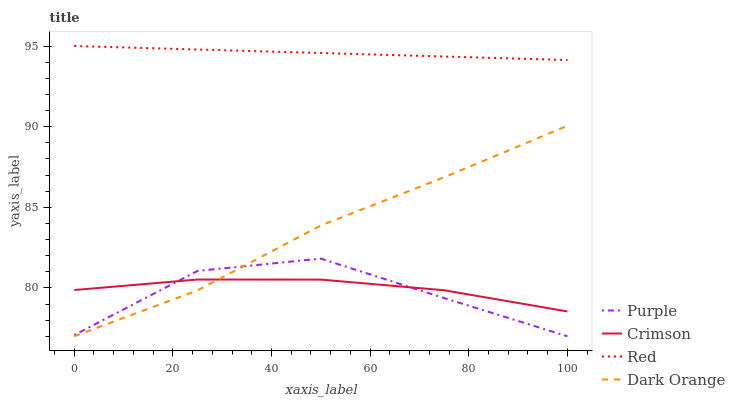Does Purple have the minimum area under the curve?
Answer yes or no. Yes. Does Red have the maximum area under the curve?
Answer yes or no. Yes. Does Crimson have the minimum area under the curve?
Answer yes or no. No. Does Crimson have the maximum area under the curve?
Answer yes or no. No. Is Red the smoothest?
Answer yes or no. Yes. Is Purple the roughest?
Answer yes or no. Yes. Is Crimson the smoothest?
Answer yes or no. No. Is Crimson the roughest?
Answer yes or no. No. Does Purple have the lowest value?
Answer yes or no. Yes. Does Crimson have the lowest value?
Answer yes or no. No. Does Red have the highest value?
Answer yes or no. Yes. Does Crimson have the highest value?
Answer yes or no. No. Is Dark Orange less than Red?
Answer yes or no. Yes. Is Red greater than Purple?
Answer yes or no. Yes. Does Purple intersect Crimson?
Answer yes or no. Yes. Is Purple less than Crimson?
Answer yes or no. No. Is Purple greater than Crimson?
Answer yes or no. No. Does Dark Orange intersect Red?
Answer yes or no. No. 